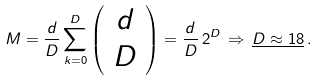<formula> <loc_0><loc_0><loc_500><loc_500>M = \frac { d } { D } \sum _ { k = 0 } ^ { D } \left ( \begin{array} { c } d \\ D \end{array} \right ) = \frac { d } { D } \, 2 ^ { D } \, \Rightarrow \, \underline { D \approx 1 8 } \, .</formula> 